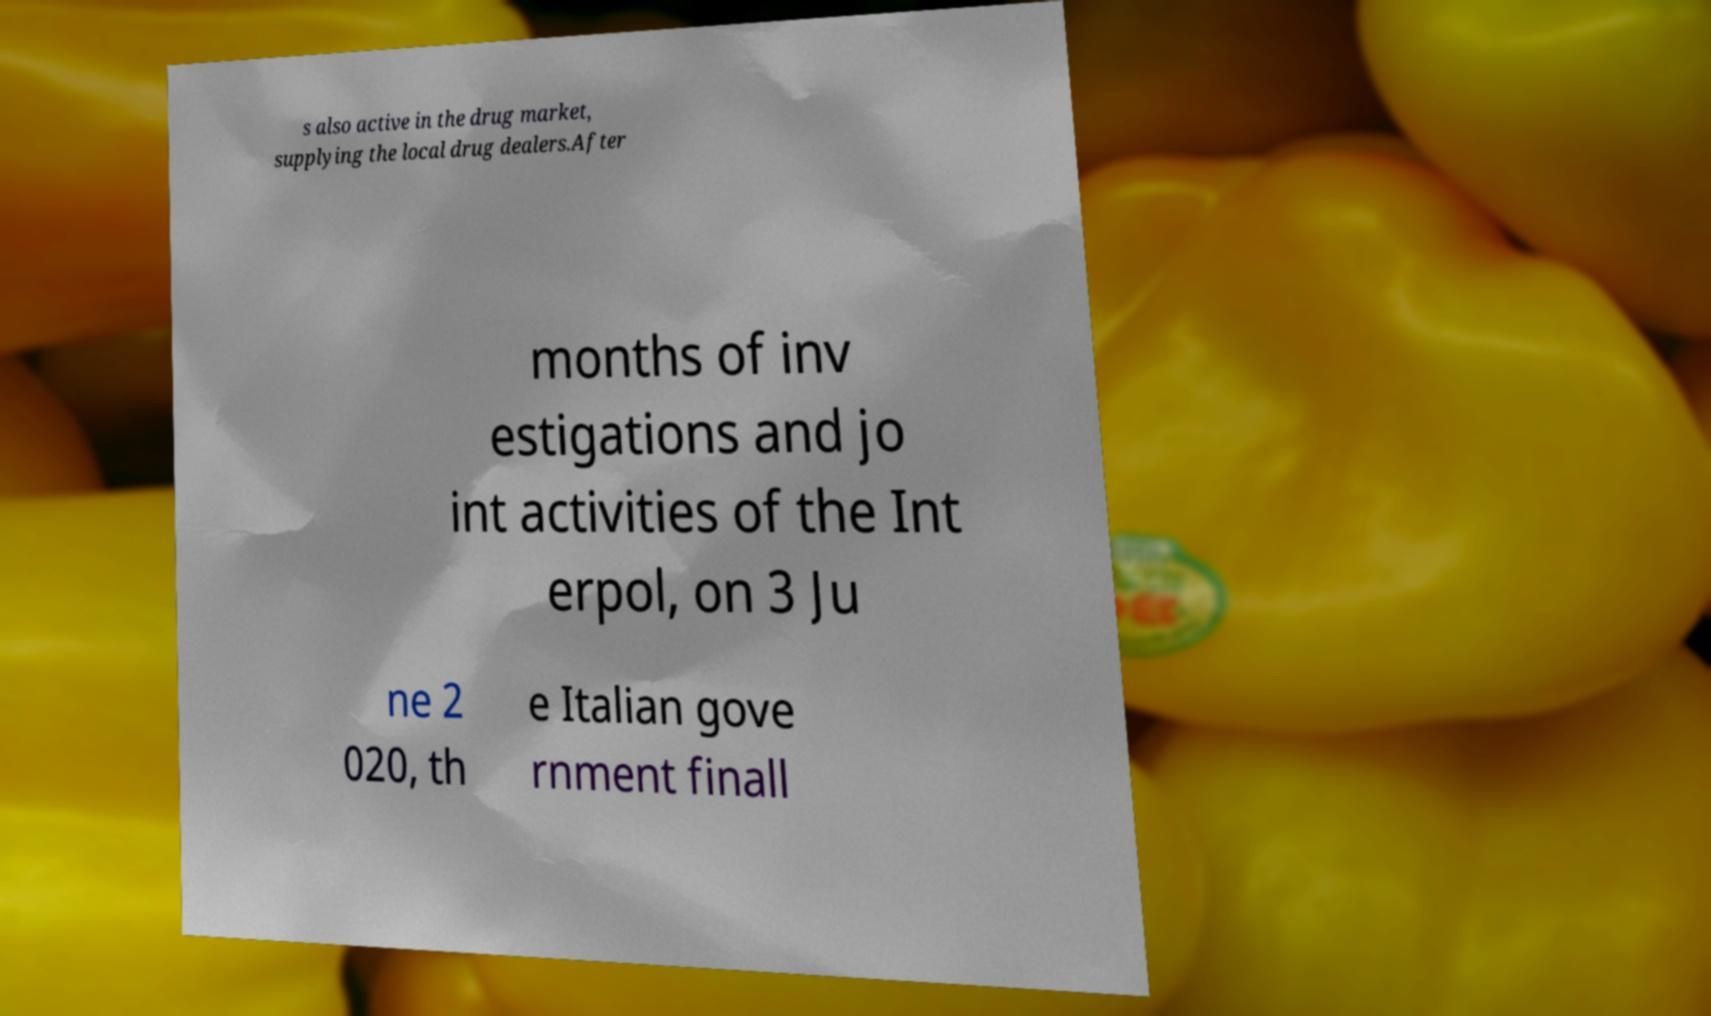For documentation purposes, I need the text within this image transcribed. Could you provide that? s also active in the drug market, supplying the local drug dealers.After months of inv estigations and jo int activities of the Int erpol, on 3 Ju ne 2 020, th e Italian gove rnment finall 